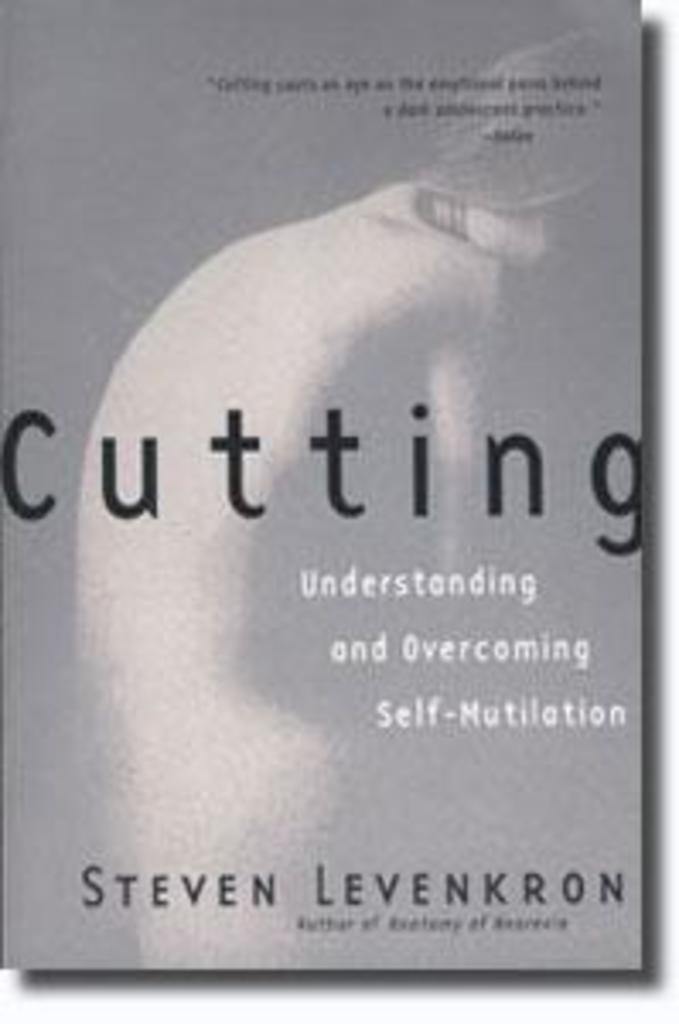Provide a one-sentence caption for the provided image. The cover of the book Cutting: Understanding and Overcoming Self-Mutilation. 